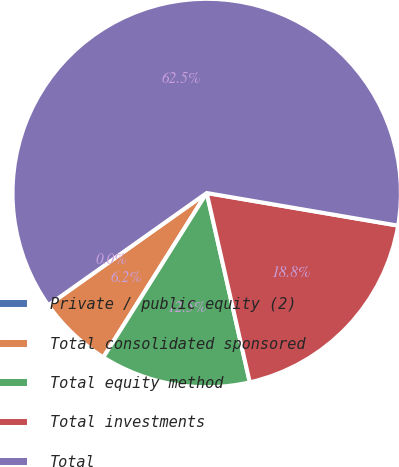Convert chart to OTSL. <chart><loc_0><loc_0><loc_500><loc_500><pie_chart><fcel>Private / public equity (2)<fcel>Total consolidated sponsored<fcel>Total equity method<fcel>Total investments<fcel>Total<nl><fcel>0.0%<fcel>6.25%<fcel>12.5%<fcel>18.75%<fcel>62.5%<nl></chart> 